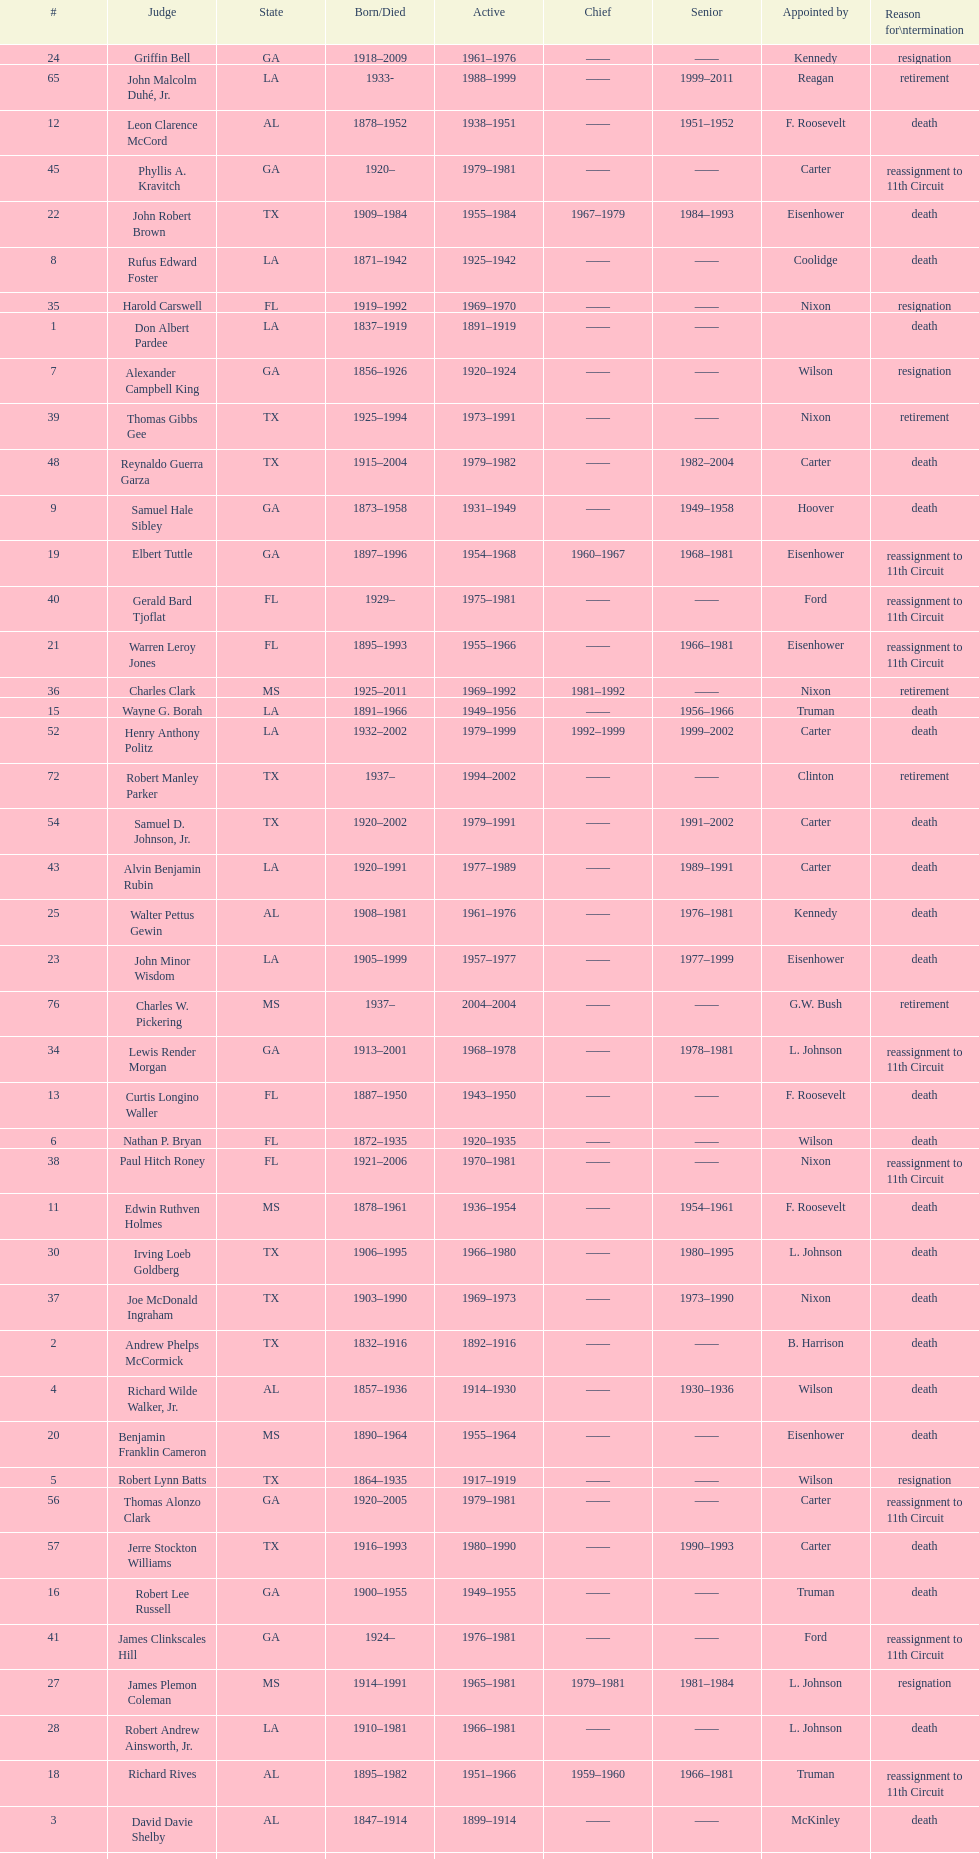How many judges were appointed by president carter? 13. 